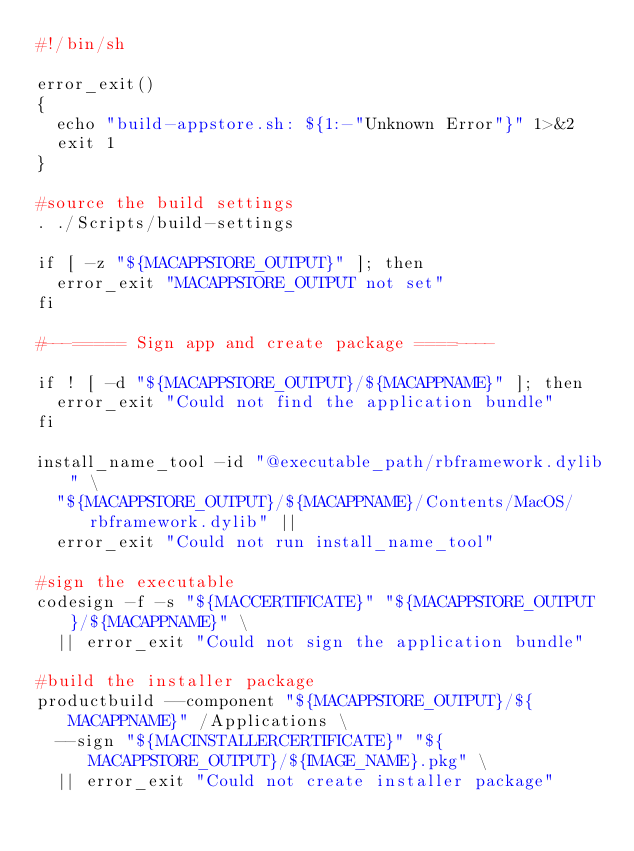Convert code to text. <code><loc_0><loc_0><loc_500><loc_500><_Bash_>#!/bin/sh

error_exit()
{
	echo "build-appstore.sh: ${1:-"Unknown Error"}" 1>&2
	exit 1
}

#source the build settings
. ./Scripts/build-settings

if [ -z "${MACAPPSTORE_OUTPUT}" ]; then
	error_exit "MACAPPSTORE_OUTPUT not set"
fi

#---===== Sign app and create package ====----

if ! [ -d "${MACAPPSTORE_OUTPUT}/${MACAPPNAME}" ]; then
	error_exit "Could not find the application bundle"
fi

install_name_tool -id "@executable_path/rbframework.dylib" \
	"${MACAPPSTORE_OUTPUT}/${MACAPPNAME}/Contents/MacOS/rbframework.dylib" ||
	error_exit "Could not run install_name_tool"

#sign the executable
codesign -f -s "${MACCERTIFICATE}" "${MACAPPSTORE_OUTPUT}/${MACAPPNAME}" \
	|| error_exit "Could not sign the application bundle"

#build the installer package
productbuild --component "${MACAPPSTORE_OUTPUT}/${MACAPPNAME}" /Applications \
	--sign "${MACINSTALLERCERTIFICATE}" "${MACAPPSTORE_OUTPUT}/${IMAGE_NAME}.pkg" \
	|| error_exit "Could not create installer package"</code> 